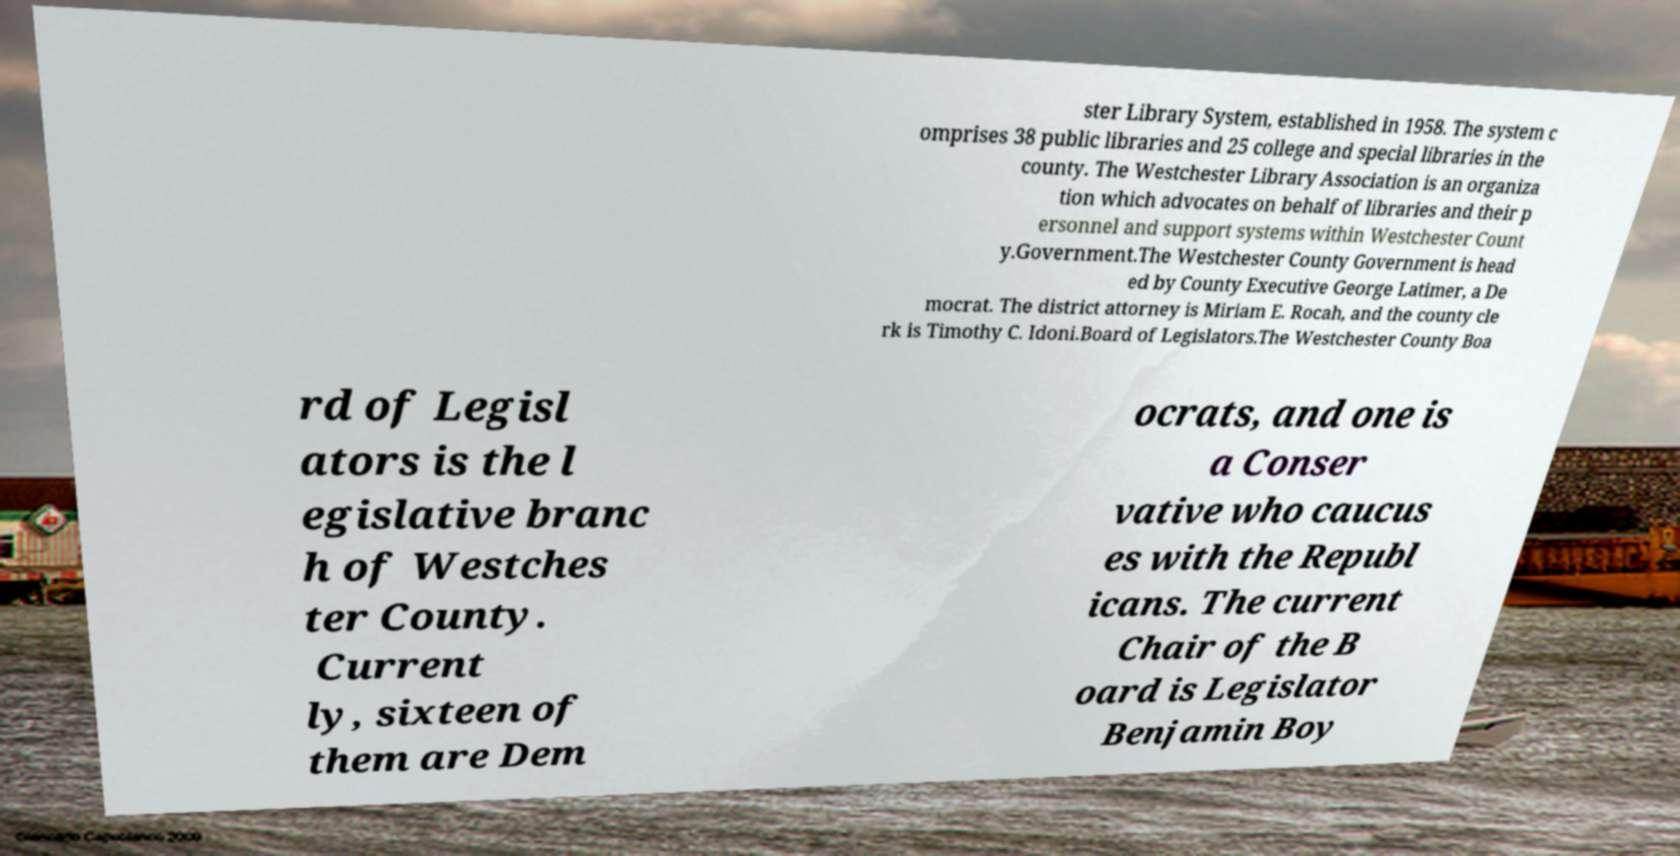Can you read and provide the text displayed in the image?This photo seems to have some interesting text. Can you extract and type it out for me? ster Library System, established in 1958. The system c omprises 38 public libraries and 25 college and special libraries in the county. The Westchester Library Association is an organiza tion which advocates on behalf of libraries and their p ersonnel and support systems within Westchester Count y.Government.The Westchester County Government is head ed by County Executive George Latimer, a De mocrat. The district attorney is Miriam E. Rocah, and the county cle rk is Timothy C. Idoni.Board of Legislators.The Westchester County Boa rd of Legisl ators is the l egislative branc h of Westches ter County. Current ly, sixteen of them are Dem ocrats, and one is a Conser vative who caucus es with the Republ icans. The current Chair of the B oard is Legislator Benjamin Boy 